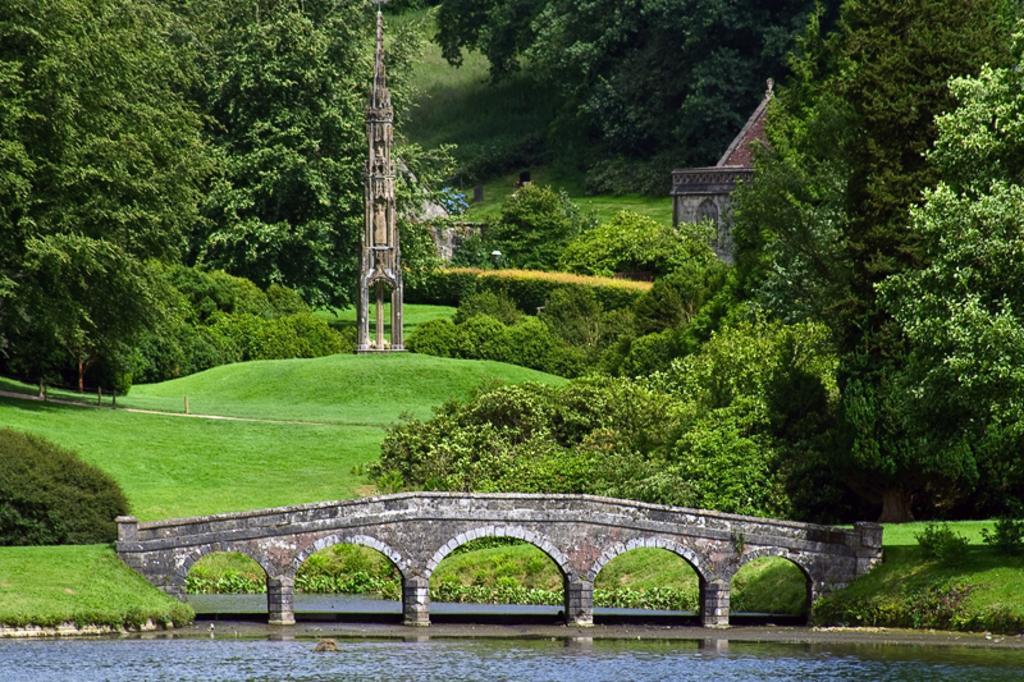In one or two sentences, can you explain what this image depicts? In the image in front there is water. In the center of the image there is a bridge. At the bottom of the image there is grass on the surface. In the background of the image there are plants, buildings, trees and sky. 